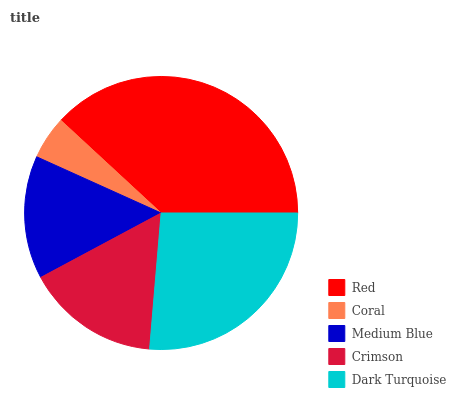Is Coral the minimum?
Answer yes or no. Yes. Is Red the maximum?
Answer yes or no. Yes. Is Medium Blue the minimum?
Answer yes or no. No. Is Medium Blue the maximum?
Answer yes or no. No. Is Medium Blue greater than Coral?
Answer yes or no. Yes. Is Coral less than Medium Blue?
Answer yes or no. Yes. Is Coral greater than Medium Blue?
Answer yes or no. No. Is Medium Blue less than Coral?
Answer yes or no. No. Is Crimson the high median?
Answer yes or no. Yes. Is Crimson the low median?
Answer yes or no. Yes. Is Red the high median?
Answer yes or no. No. Is Medium Blue the low median?
Answer yes or no. No. 